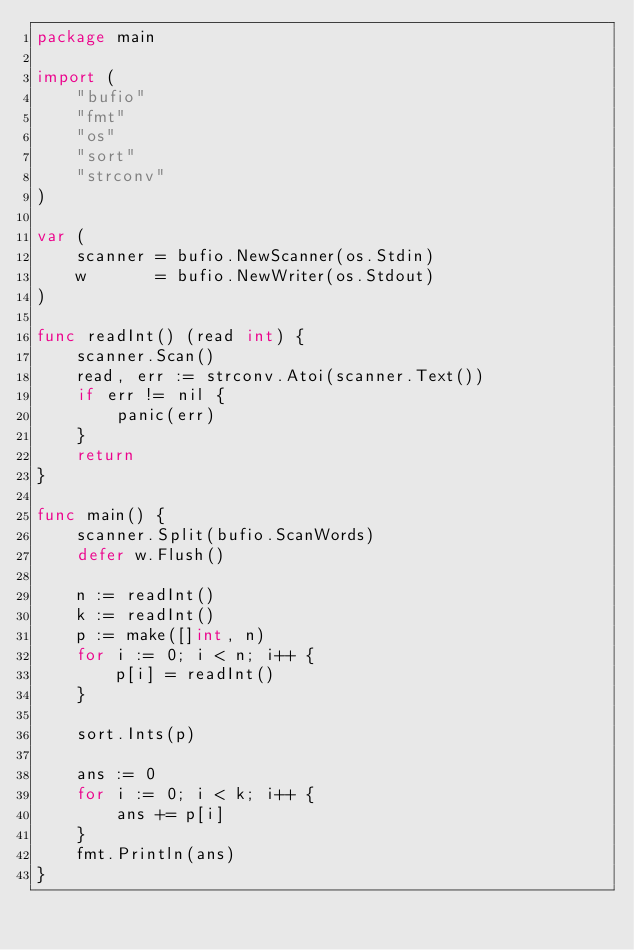Convert code to text. <code><loc_0><loc_0><loc_500><loc_500><_Go_>package main

import (
	"bufio"
	"fmt"
	"os"
	"sort"
	"strconv"
)

var (
	scanner = bufio.NewScanner(os.Stdin)
	w       = bufio.NewWriter(os.Stdout)
)

func readInt() (read int) {
	scanner.Scan()
	read, err := strconv.Atoi(scanner.Text())
	if err != nil {
		panic(err)
	}
	return
}

func main() {
	scanner.Split(bufio.ScanWords)
	defer w.Flush()

	n := readInt()
	k := readInt()
	p := make([]int, n)
	for i := 0; i < n; i++ {
		p[i] = readInt()
	}

	sort.Ints(p)

	ans := 0
	for i := 0; i < k; i++ {
		ans += p[i]
	}
	fmt.Println(ans)
}</code> 